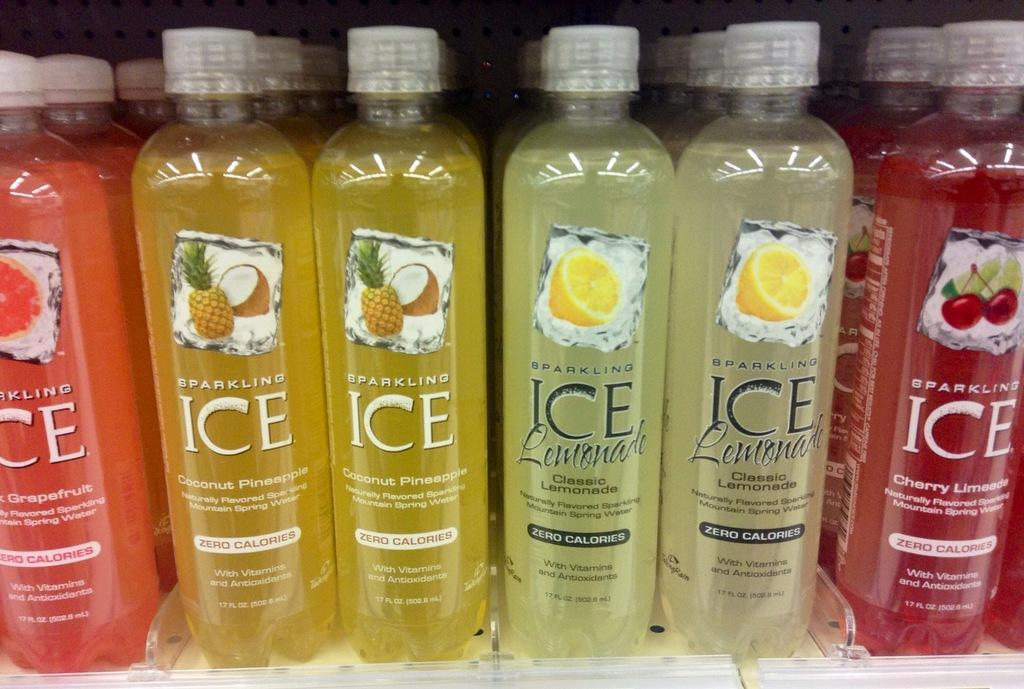<image>
Render a clear and concise summary of the photo. shelf with several varieties of sparkling ice including grapefruit, coconut pineapple, classic lemonade, and cherry limeade 